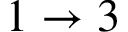<formula> <loc_0><loc_0><loc_500><loc_500>1 \rightarrow 3</formula> 